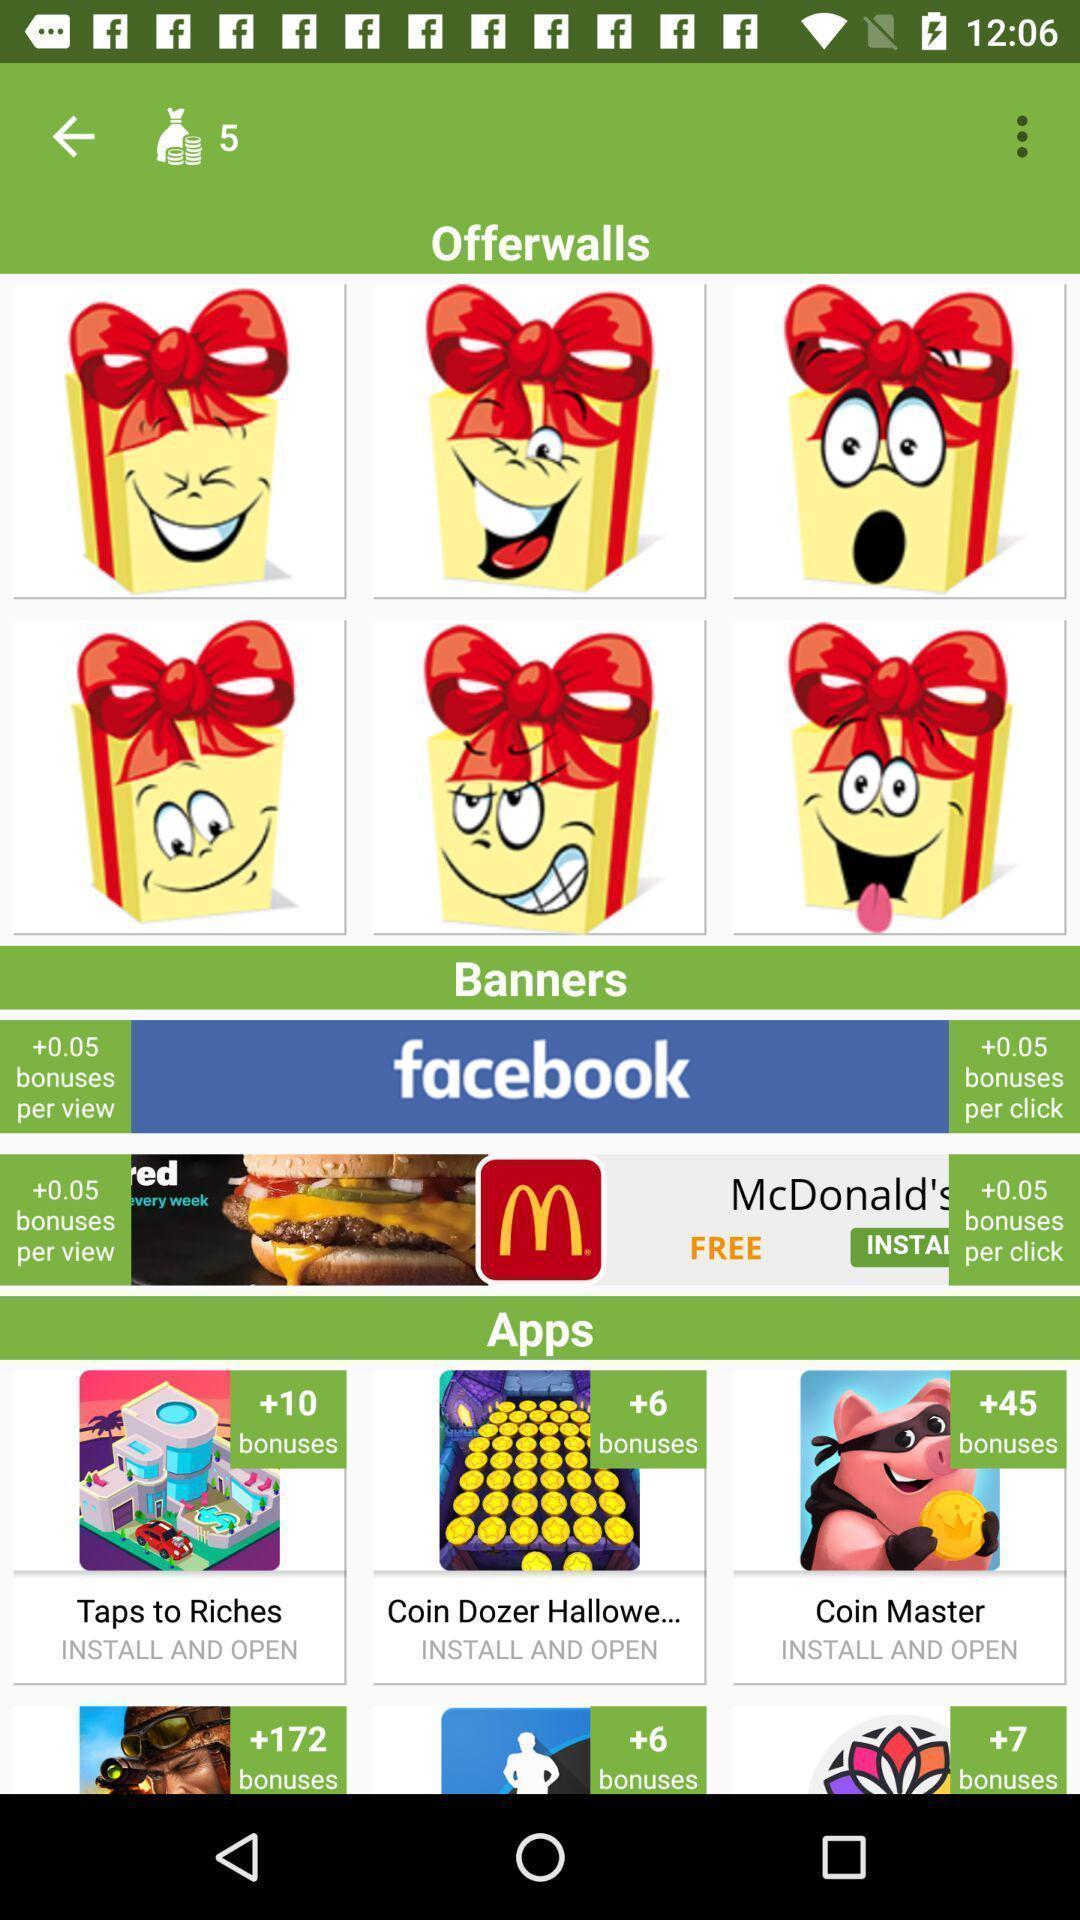Provide a textual representation of this image. Page displaying stickers in the app. 